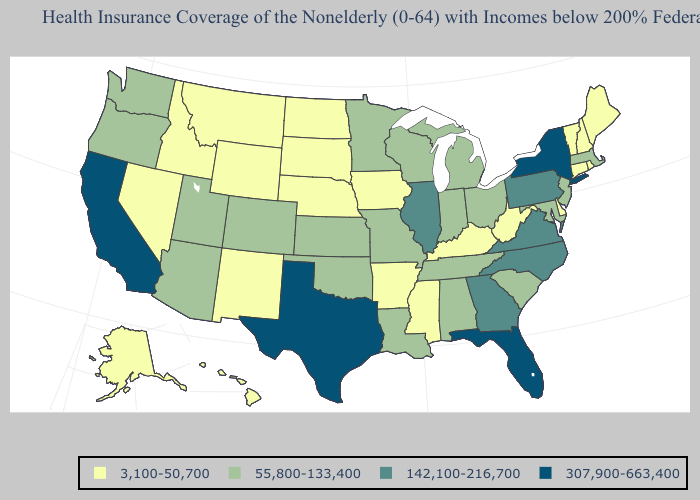What is the value of New York?
Give a very brief answer. 307,900-663,400. Does Oregon have the lowest value in the USA?
Keep it brief. No. Does the first symbol in the legend represent the smallest category?
Short answer required. Yes. Does Arizona have a lower value than Maine?
Write a very short answer. No. Name the states that have a value in the range 142,100-216,700?
Concise answer only. Georgia, Illinois, North Carolina, Pennsylvania, Virginia. What is the lowest value in the Northeast?
Give a very brief answer. 3,100-50,700. What is the value of Hawaii?
Be succinct. 3,100-50,700. Does Washington have the same value as Ohio?
Short answer required. Yes. What is the value of Rhode Island?
Give a very brief answer. 3,100-50,700. Name the states that have a value in the range 142,100-216,700?
Give a very brief answer. Georgia, Illinois, North Carolina, Pennsylvania, Virginia. What is the lowest value in the USA?
Short answer required. 3,100-50,700. What is the lowest value in the Northeast?
Keep it brief. 3,100-50,700. Which states have the lowest value in the West?
Keep it brief. Alaska, Hawaii, Idaho, Montana, Nevada, New Mexico, Wyoming. What is the value of Georgia?
Give a very brief answer. 142,100-216,700. What is the lowest value in states that border Arkansas?
Write a very short answer. 3,100-50,700. 